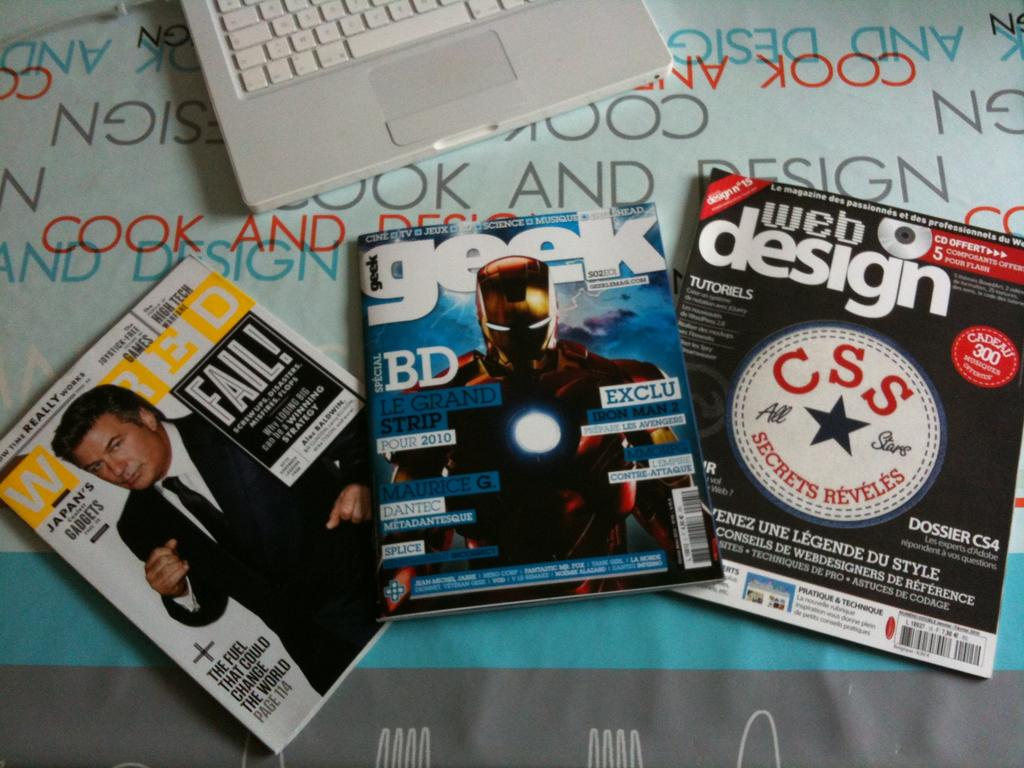Provide a one-sentence caption for the provided image. A number of computer magazines are spread out on a desk for Wired and Geek magazines. 